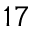<formula> <loc_0><loc_0><loc_500><loc_500>^ { 1 7 }</formula> 